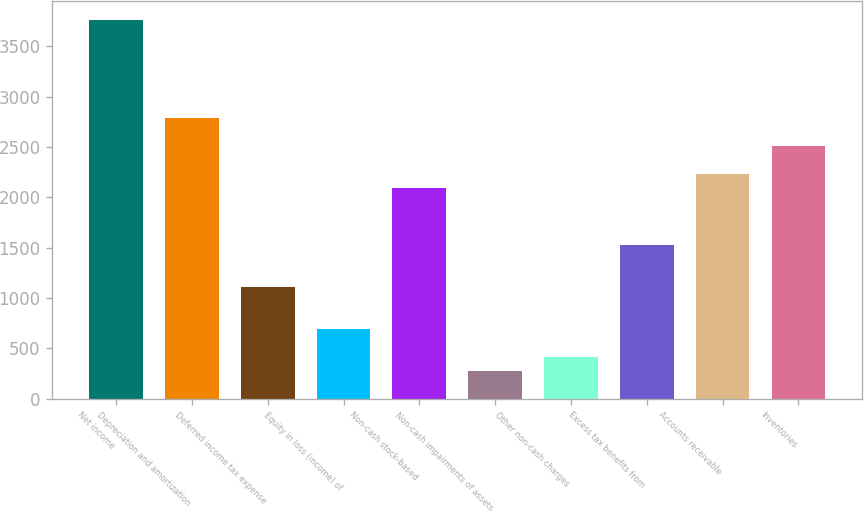Convert chart. <chart><loc_0><loc_0><loc_500><loc_500><bar_chart><fcel>Net income<fcel>Depreciation and amortization<fcel>Deferred income tax expense<fcel>Equity in loss (income) of<fcel>Non-cash stock-based<fcel>Non-cash impairments of assets<fcel>Other non-cash charges<fcel>Excess tax benefits from<fcel>Accounts receivable<fcel>Inventories<nl><fcel>3762.11<fcel>2786.8<fcel>1114.84<fcel>696.85<fcel>2090.15<fcel>278.86<fcel>418.19<fcel>1532.83<fcel>2229.48<fcel>2508.14<nl></chart> 